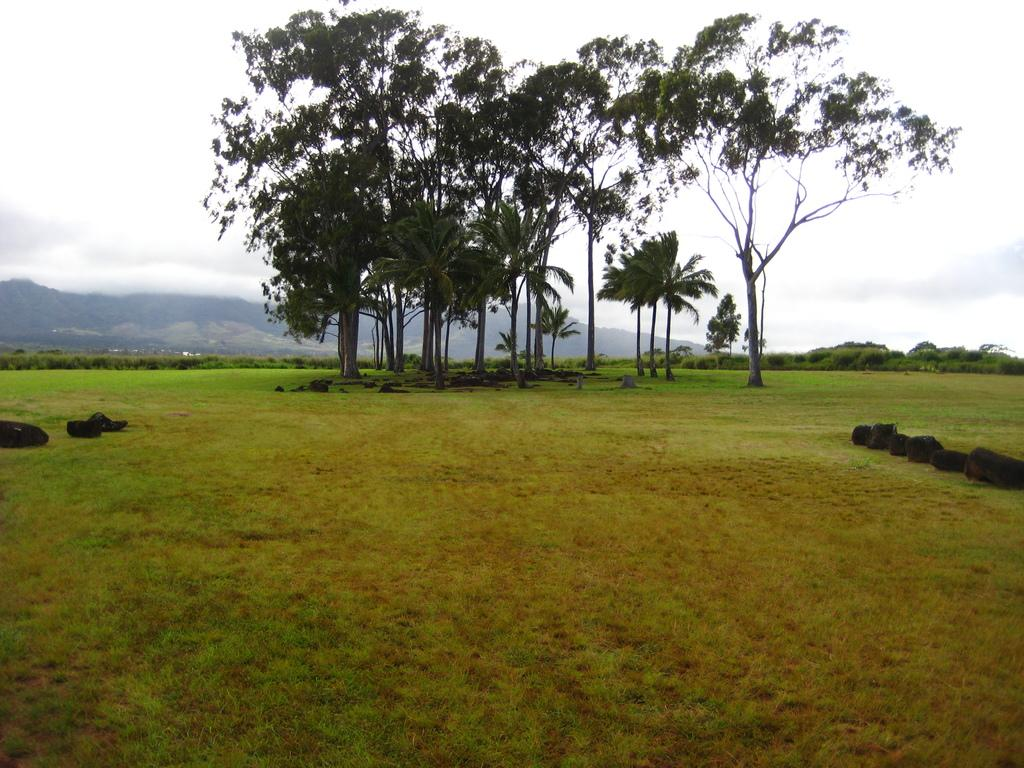What type of vegetation can be seen in the image? There is grass in the image. What can be seen in the distance in the image? There are trees in the background of the image. What is visible in the sky in the background of the image? There are clouds in the sky in the background of the image. What type of polish is being applied to the trees in the image? There is no indication in the image that any polish is being applied to the trees. 